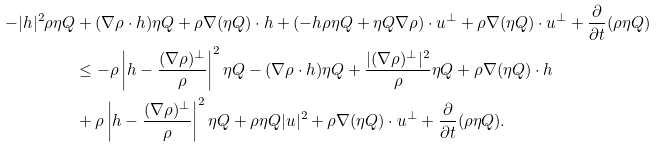<formula> <loc_0><loc_0><loc_500><loc_500>- | h | ^ { 2 } \rho \eta Q & + ( \nabla \rho \cdot h ) \eta Q + \rho \nabla ( \eta Q ) \cdot h + ( - h \rho \eta Q + \eta Q \nabla \rho ) \cdot u ^ { \perp } + \rho \nabla ( \eta Q ) \cdot u ^ { \perp } + \frac { \partial } { \partial t } ( \rho \eta Q ) \\ & \leq - \rho \left | h - \frac { ( \nabla \rho ) ^ { \perp } } { \rho } \right | ^ { 2 } \eta Q - ( \nabla \rho \cdot h ) \eta Q + \frac { | ( \nabla \rho ) ^ { \perp } | ^ { 2 } } { \rho } \eta Q + \rho \nabla ( \eta Q ) \cdot h \\ & + \rho \left | h - \frac { ( \nabla \rho ) ^ { \perp } } { \rho } \right | ^ { 2 } \eta Q + \rho \eta Q | u | ^ { 2 } + \rho \nabla ( \eta Q ) \cdot u ^ { \perp } + \frac { \partial } { \partial t } ( \rho \eta Q ) .</formula> 